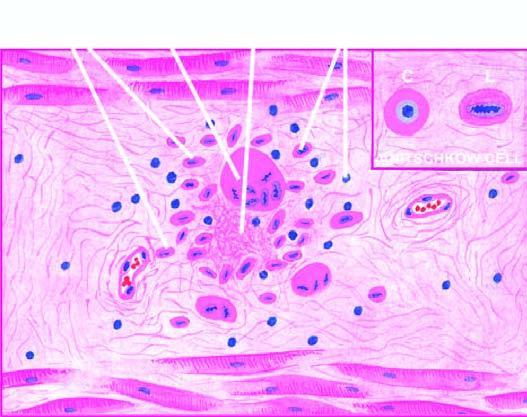does inbox show anitschkow cell in longitudinal section with caterpillar-like serrated nuclear chromatin, while cross section cs shows owl-eye appearance of central chromatin mass and perinuclear halo?
Answer the question using a single word or phrase. Yes 